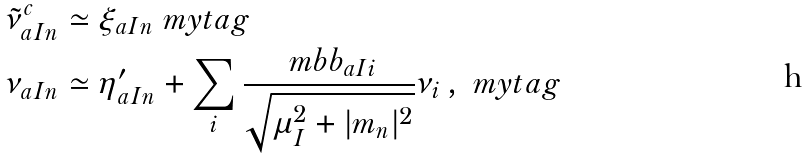<formula> <loc_0><loc_0><loc_500><loc_500>\tilde { \nu } ^ { c } _ { a I n } & \simeq \xi _ { a I n } \ m y t a g \\ \nu _ { a I n } & \simeq \eta ^ { \prime } _ { a I n } + \sum _ { i } \frac { \ m b b _ { a I i } } { \sqrt { \mu ^ { 2 } _ { I } + | m _ { n } | ^ { 2 } } } \nu _ { i } \, , \ m y t a g</formula> 